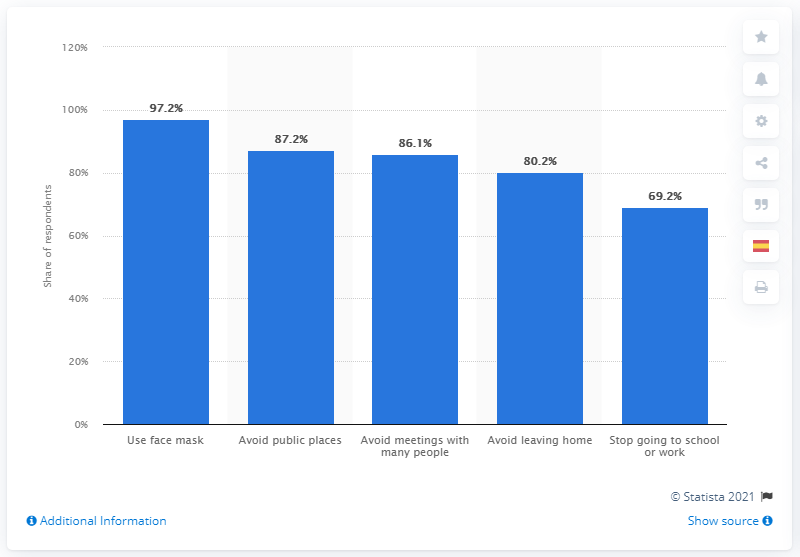Mention a couple of crucial points in this snapshot. According to the given diagram, face masks are the prevention method that has the highest percentage of responses. The difference between the highest and lowest responses in percentages is the range of the responses. 